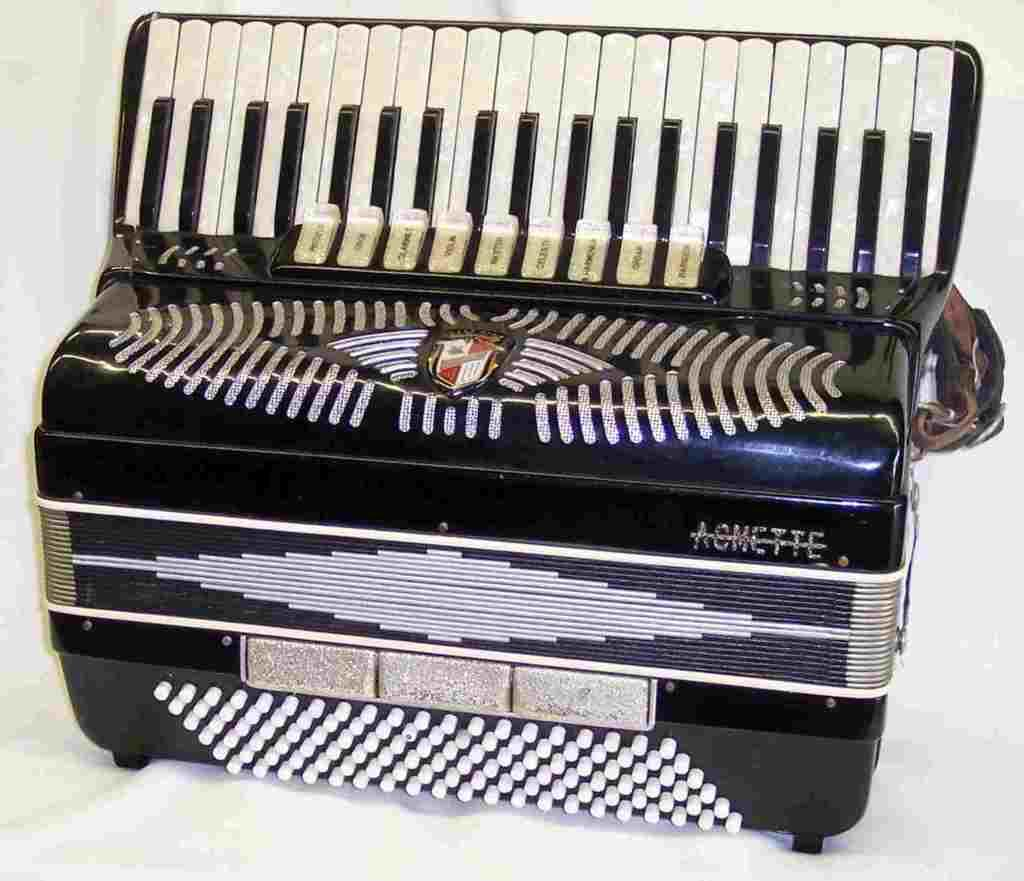What is the main subject of the image? There is a musical instrument in the center of the image. What type of rice is being used to write with the quill on the coat in the image? There is no rice, quill, or coat present in the image; it only features a musical instrument. 